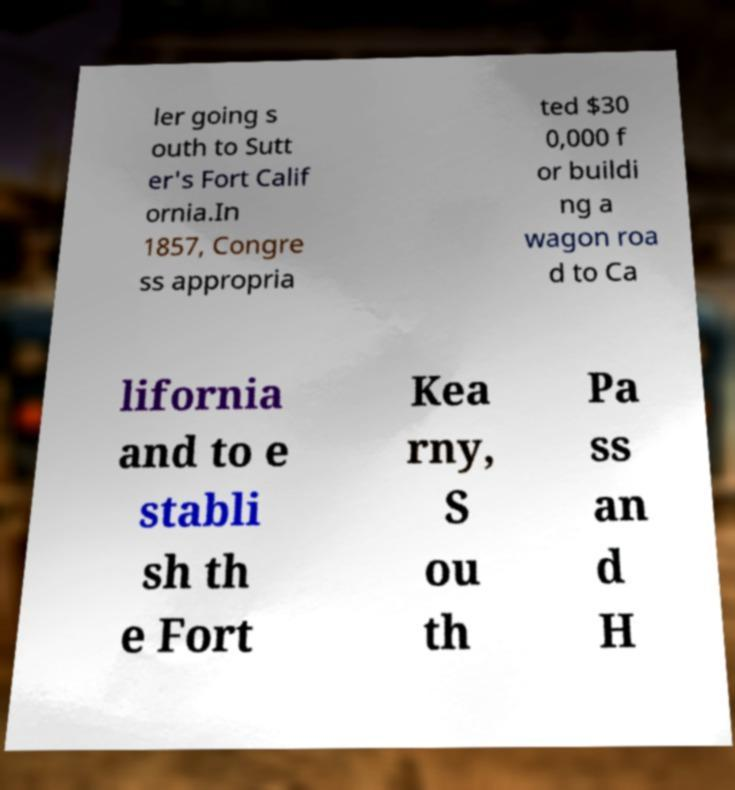Please identify and transcribe the text found in this image. ler going s outh to Sutt er's Fort Calif ornia.In 1857, Congre ss appropria ted $30 0,000 f or buildi ng a wagon roa d to Ca lifornia and to e stabli sh th e Fort Kea rny, S ou th Pa ss an d H 